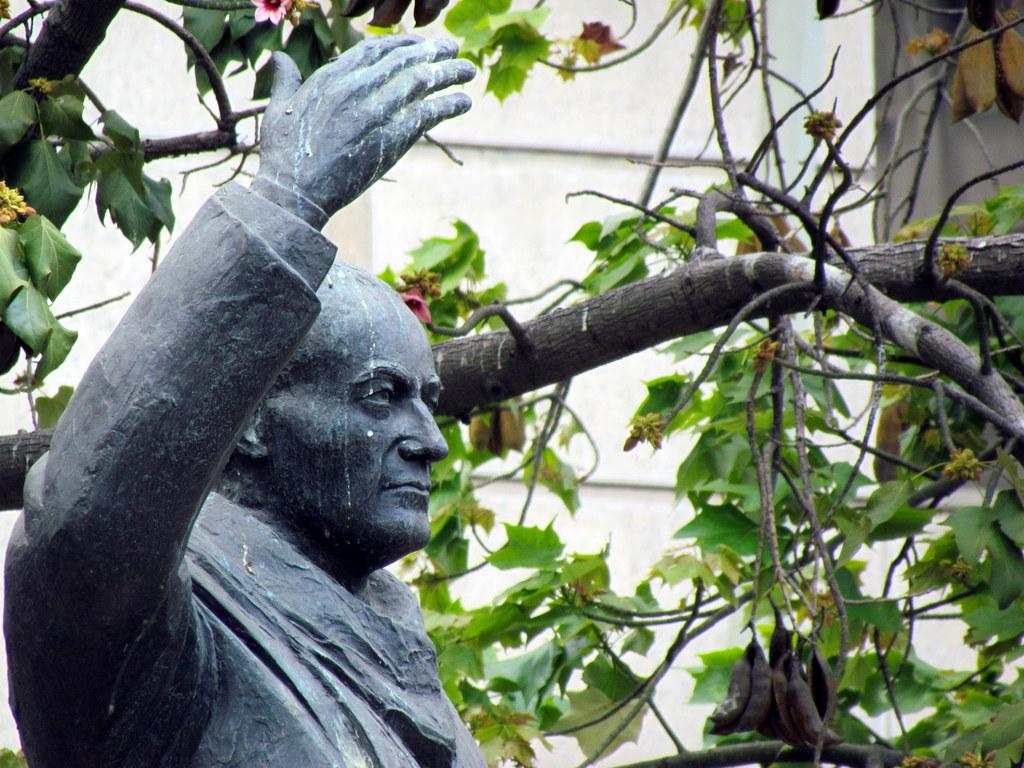What is the main subject in the foreground of the image? There is a man's sculpture in the foreground of the image. What can be seen behind the sculpture? There is a tree with flowers behind the sculpture. What architectural feature is visible in the background of the image? There is a wall visible in the background of the image. What type of ray is causing the flowers to bloom in the image? There is no ray present in the image, and therefore no such cause can be observed. 